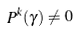Convert formula to latex. <formula><loc_0><loc_0><loc_500><loc_500>P ^ { k } ( \gamma ) \neq 0</formula> 